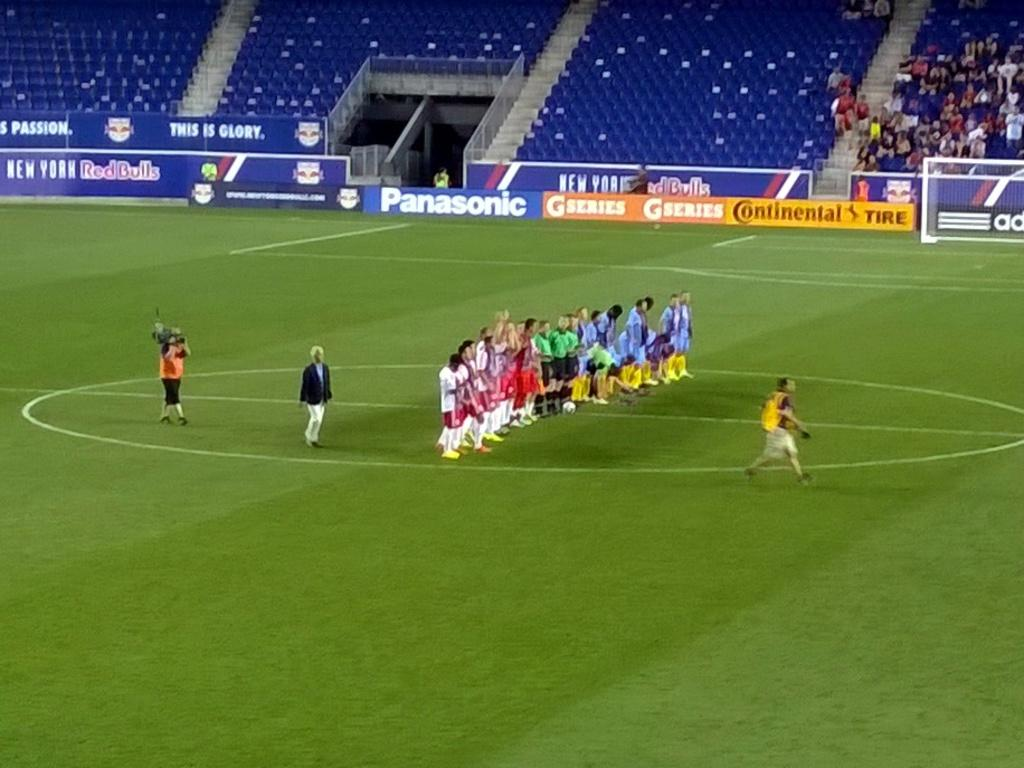Provide a one-sentence caption for the provided image. Several soccer players are on the field, which has a Panasonic banner on the wall. 